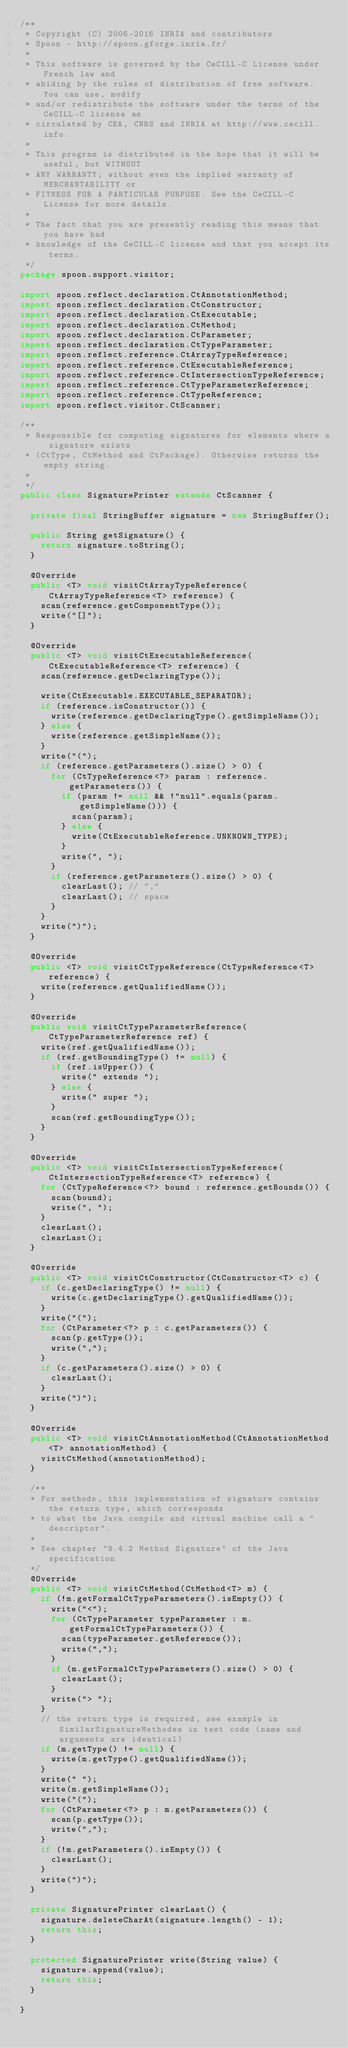<code> <loc_0><loc_0><loc_500><loc_500><_Java_>/**
 * Copyright (C) 2006-2016 INRIA and contributors
 * Spoon - http://spoon.gforge.inria.fr/
 *
 * This software is governed by the CeCILL-C License under French law and
 * abiding by the rules of distribution of free software. You can use, modify
 * and/or redistribute the software under the terms of the CeCILL-C license as
 * circulated by CEA, CNRS and INRIA at http://www.cecill.info.
 *
 * This program is distributed in the hope that it will be useful, but WITHOUT
 * ANY WARRANTY; without even the implied warranty of MERCHANTABILITY or
 * FITNESS FOR A PARTICULAR PURPOSE. See the CeCILL-C License for more details.
 *
 * The fact that you are presently reading this means that you have had
 * knowledge of the CeCILL-C license and that you accept its terms.
 */
package spoon.support.visitor;

import spoon.reflect.declaration.CtAnnotationMethod;
import spoon.reflect.declaration.CtConstructor;
import spoon.reflect.declaration.CtExecutable;
import spoon.reflect.declaration.CtMethod;
import spoon.reflect.declaration.CtParameter;
import spoon.reflect.declaration.CtTypeParameter;
import spoon.reflect.reference.CtArrayTypeReference;
import spoon.reflect.reference.CtExecutableReference;
import spoon.reflect.reference.CtIntersectionTypeReference;
import spoon.reflect.reference.CtTypeParameterReference;
import spoon.reflect.reference.CtTypeReference;
import spoon.reflect.visitor.CtScanner;

/**
 * Responsible for computing signatures for elements where a signature exists
 * (CtType, CtMethod and CtPackage). Otherwise returns the empty string.
 *
 */
public class SignaturePrinter extends CtScanner {

	private final StringBuffer signature = new StringBuffer();

	public String getSignature() {
		return signature.toString();
	}

	@Override
	public <T> void visitCtArrayTypeReference(CtArrayTypeReference<T> reference) {
		scan(reference.getComponentType());
		write("[]");
	}

	@Override
	public <T> void visitCtExecutableReference(CtExecutableReference<T> reference) {
		scan(reference.getDeclaringType());

		write(CtExecutable.EXECUTABLE_SEPARATOR);
		if (reference.isConstructor()) {
			write(reference.getDeclaringType().getSimpleName());
		} else {
			write(reference.getSimpleName());
		}
		write("(");
		if (reference.getParameters().size() > 0) {
			for (CtTypeReference<?> param : reference.getParameters()) {
				if (param != null && !"null".equals(param.getSimpleName())) {
					scan(param);
				} else {
					write(CtExecutableReference.UNKNOWN_TYPE);
				}
				write(", ");
			}
			if (reference.getParameters().size() > 0) {
				clearLast(); // ","
				clearLast(); // space
			}
		}
		write(")");
	}

	@Override
	public <T> void visitCtTypeReference(CtTypeReference<T> reference) {
		write(reference.getQualifiedName());
	}

	@Override
	public void visitCtTypeParameterReference(CtTypeParameterReference ref) {
		write(ref.getQualifiedName());
		if (ref.getBoundingType() != null) {
			if (ref.isUpper()) {
				write(" extends ");
			} else {
				write(" super ");
			}
			scan(ref.getBoundingType());
		}
	}

	@Override
	public <T> void visitCtIntersectionTypeReference(CtIntersectionTypeReference<T> reference) {
		for (CtTypeReference<?> bound : reference.getBounds()) {
			scan(bound);
			write(", ");
		}
		clearLast();
		clearLast();
	}

	@Override
	public <T> void visitCtConstructor(CtConstructor<T> c) {
		if (c.getDeclaringType() != null) {
			write(c.getDeclaringType().getQualifiedName());
		}
		write("(");
		for (CtParameter<?> p : c.getParameters()) {
			scan(p.getType());
			write(",");
		}
		if (c.getParameters().size() > 0) {
			clearLast();
		}
		write(")");
	}

	@Override
	public <T> void visitCtAnnotationMethod(CtAnnotationMethod<T> annotationMethod) {
		visitCtMethod(annotationMethod);
	}

	/**
	* For methods, this implementation of signature contains the return type, which corresponds
	* to what the Java compile and virtual machine call a "descriptor".
	*
	* See chapter "8.4.2 Method Signature" of the Java specification
	*/
	@Override
	public <T> void visitCtMethod(CtMethod<T> m) {
		if (!m.getFormalCtTypeParameters().isEmpty()) {
			write("<");
			for (CtTypeParameter typeParameter : m.getFormalCtTypeParameters()) {
				scan(typeParameter.getReference());
				write(",");
			}
			if (m.getFormalCtTypeParameters().size() > 0) {
				clearLast();
			}
			write("> ");
		}
		// the return type is required, see example in SimilarSignatureMethodes in test code (name and arguments are identical)
		if (m.getType() != null) {
			write(m.getType().getQualifiedName());
		}
		write(" ");
		write(m.getSimpleName());
		write("(");
		for (CtParameter<?> p : m.getParameters()) {
			scan(p.getType());
			write(",");
		}
		if (!m.getParameters().isEmpty()) {
			clearLast();
		}
		write(")");
	}

	private SignaturePrinter clearLast() {
		signature.deleteCharAt(signature.length() - 1);
		return this;
	}

	protected SignaturePrinter write(String value) {
		signature.append(value);
		return this;
	}

}
</code> 